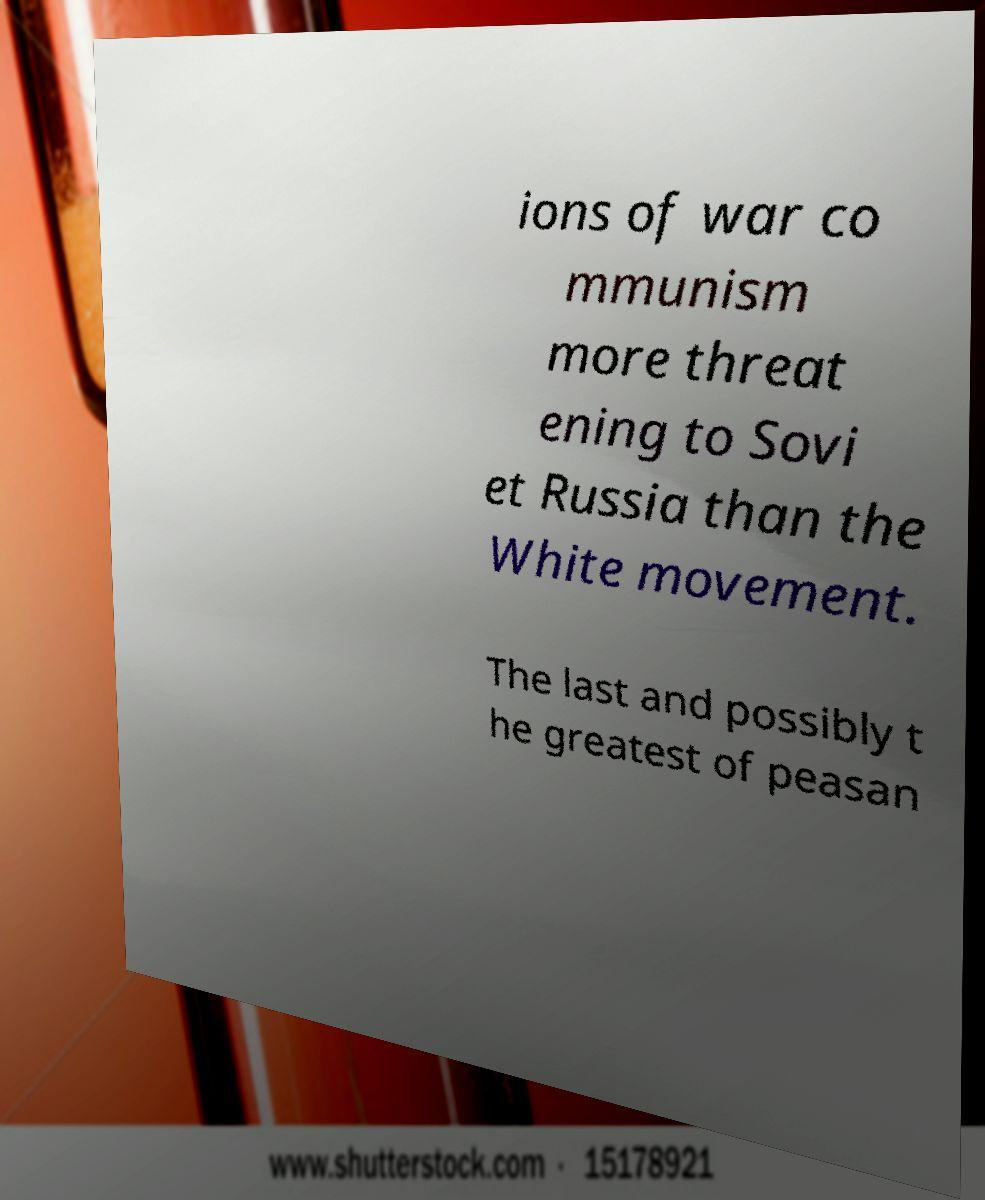Could you extract and type out the text from this image? ions of war co mmunism more threat ening to Sovi et Russia than the White movement. The last and possibly t he greatest of peasan 